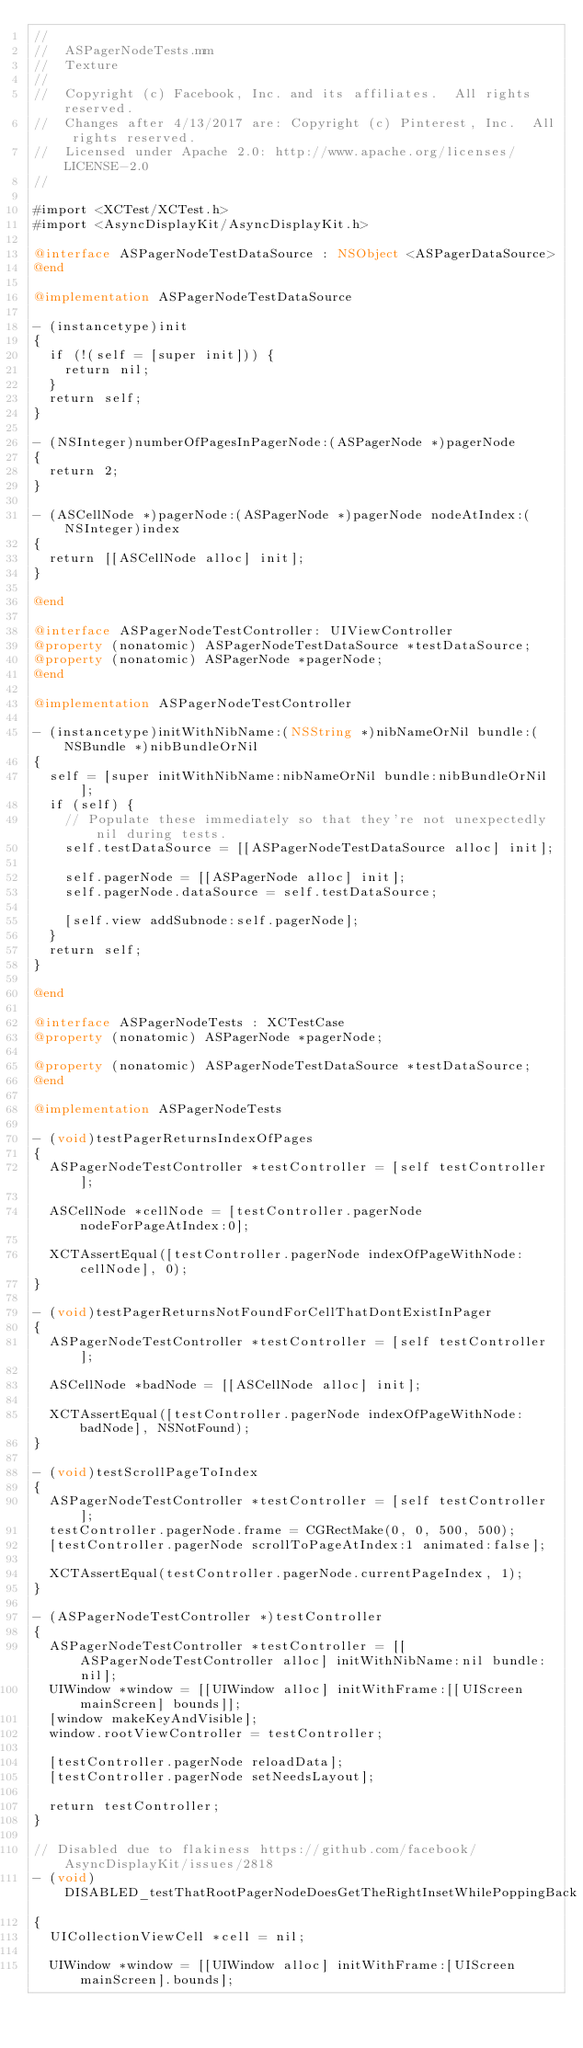<code> <loc_0><loc_0><loc_500><loc_500><_ObjectiveC_>//
//  ASPagerNodeTests.mm
//  Texture
//
//  Copyright (c) Facebook, Inc. and its affiliates.  All rights reserved.
//  Changes after 4/13/2017 are: Copyright (c) Pinterest, Inc.  All rights reserved.
//  Licensed under Apache 2.0: http://www.apache.org/licenses/LICENSE-2.0
//

#import <XCTest/XCTest.h>
#import <AsyncDisplayKit/AsyncDisplayKit.h>

@interface ASPagerNodeTestDataSource : NSObject <ASPagerDataSource>
@end

@implementation ASPagerNodeTestDataSource

- (instancetype)init
{
  if (!(self = [super init])) {
    return nil;
  }
  return self;
}

- (NSInteger)numberOfPagesInPagerNode:(ASPagerNode *)pagerNode
{
  return 2;
}

- (ASCellNode *)pagerNode:(ASPagerNode *)pagerNode nodeAtIndex:(NSInteger)index
{
  return [[ASCellNode alloc] init];
}

@end

@interface ASPagerNodeTestController: UIViewController
@property (nonatomic) ASPagerNodeTestDataSource *testDataSource;
@property (nonatomic) ASPagerNode *pagerNode;
@end

@implementation ASPagerNodeTestController

- (instancetype)initWithNibName:(NSString *)nibNameOrNil bundle:(NSBundle *)nibBundleOrNil
{
  self = [super initWithNibName:nibNameOrNil bundle:nibBundleOrNil];
  if (self) {
    // Populate these immediately so that they're not unexpectedly nil during tests.
    self.testDataSource = [[ASPagerNodeTestDataSource alloc] init];

    self.pagerNode = [[ASPagerNode alloc] init];
    self.pagerNode.dataSource = self.testDataSource;
    
    [self.view addSubnode:self.pagerNode];
  }
  return self;
}

@end

@interface ASPagerNodeTests : XCTestCase
@property (nonatomic) ASPagerNode *pagerNode;

@property (nonatomic) ASPagerNodeTestDataSource *testDataSource;
@end

@implementation ASPagerNodeTests

- (void)testPagerReturnsIndexOfPages
{
  ASPagerNodeTestController *testController = [self testController];
  
  ASCellNode *cellNode = [testController.pagerNode nodeForPageAtIndex:0];
  
  XCTAssertEqual([testController.pagerNode indexOfPageWithNode:cellNode], 0);
}

- (void)testPagerReturnsNotFoundForCellThatDontExistInPager
{
  ASPagerNodeTestController *testController = [self testController];

  ASCellNode *badNode = [[ASCellNode alloc] init];
  
  XCTAssertEqual([testController.pagerNode indexOfPageWithNode:badNode], NSNotFound);
}

- (void)testScrollPageToIndex
{
  ASPagerNodeTestController *testController = [self testController];
  testController.pagerNode.frame = CGRectMake(0, 0, 500, 500);
  [testController.pagerNode scrollToPageAtIndex:1 animated:false];

  XCTAssertEqual(testController.pagerNode.currentPageIndex, 1);
}

- (ASPagerNodeTestController *)testController
{
  ASPagerNodeTestController *testController = [[ASPagerNodeTestController alloc] initWithNibName:nil bundle:nil];
  UIWindow *window = [[UIWindow alloc] initWithFrame:[[UIScreen mainScreen] bounds]];
  [window makeKeyAndVisible];
  window.rootViewController = testController;
    
  [testController.pagerNode reloadData];
  [testController.pagerNode setNeedsLayout];
  
  return testController;
}

// Disabled due to flakiness https://github.com/facebook/AsyncDisplayKit/issues/2818
- (void)DISABLED_testThatRootPagerNodeDoesGetTheRightInsetWhilePoppingBack
{
  UICollectionViewCell *cell = nil;
  
  UIWindow *window = [[UIWindow alloc] initWithFrame:[UIScreen mainScreen].bounds];</code> 